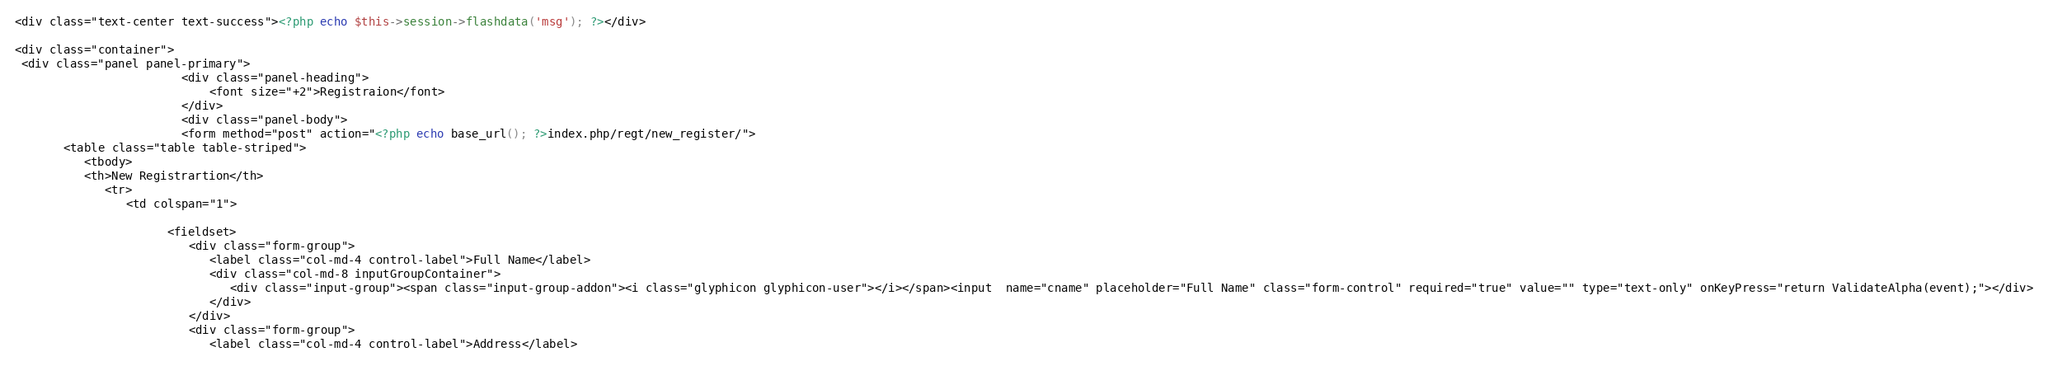<code> <loc_0><loc_0><loc_500><loc_500><_PHP_><div class="text-center text-success"><?php echo $this->session->flashdata('msg'); ?></div>

<div class="container">
 <div class="panel panel-primary">
                        <div class="panel-heading">
                            <font size="+2">Registraion</font>
                        </div>
                        <div class="panel-body">
                        <form method="post" action="<?php echo base_url(); ?>index.php/regt/new_register/">
       <table class="table table-striped">
          <tbody>
          <th>New Registrartion</th>
             <tr>
                <td colspan="1">
                   
                      <fieldset>
                         <div class="form-group">
                            <label class="col-md-4 control-label">Full Name</label>
                            <div class="col-md-8 inputGroupContainer">
                               <div class="input-group"><span class="input-group-addon"><i class="glyphicon glyphicon-user"></i></span><input  name="cname" placeholder="Full Name" class="form-control" required="true" value="" type="text-only" onKeyPress="return ValidateAlpha(event);"></div>
                            </div>
                         </div>
                         <div class="form-group">
                            <label class="col-md-4 control-label">Address</label></code> 